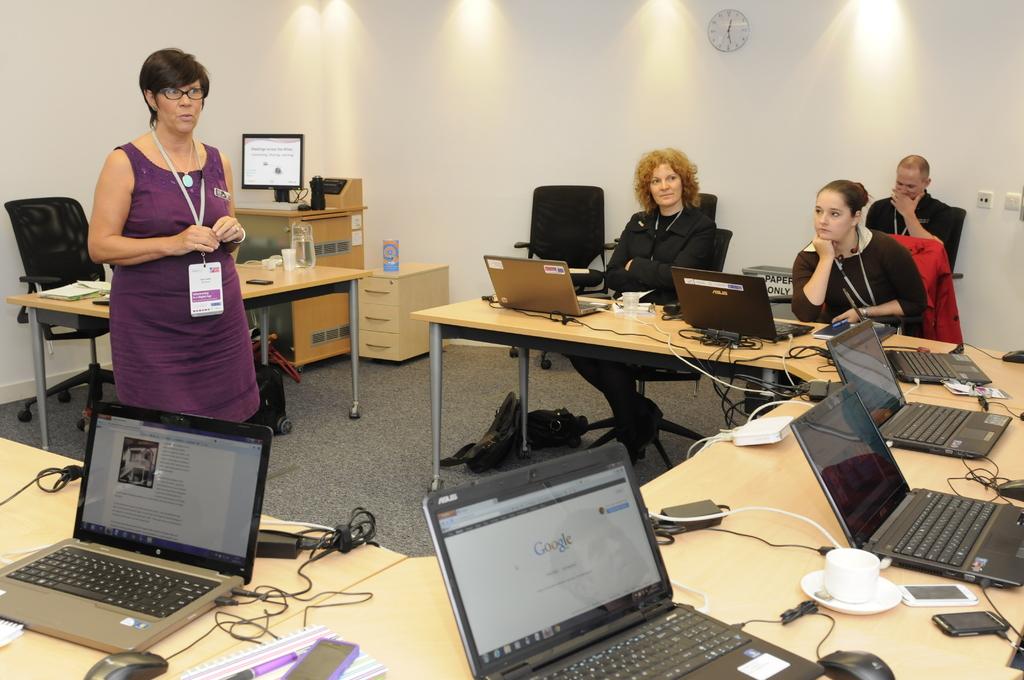What website can be seen on the laptop?
Keep it short and to the point. Google. What can you thrown in the trash bin along the back wall?
Keep it short and to the point. Paper only. 